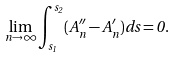<formula> <loc_0><loc_0><loc_500><loc_500>\lim _ { n \rightarrow \infty } \int _ { s _ { 1 } } ^ { s _ { 2 } } ( A _ { n } ^ { \prime \prime } - A _ { n } ^ { \prime } ) d s = 0 .</formula> 